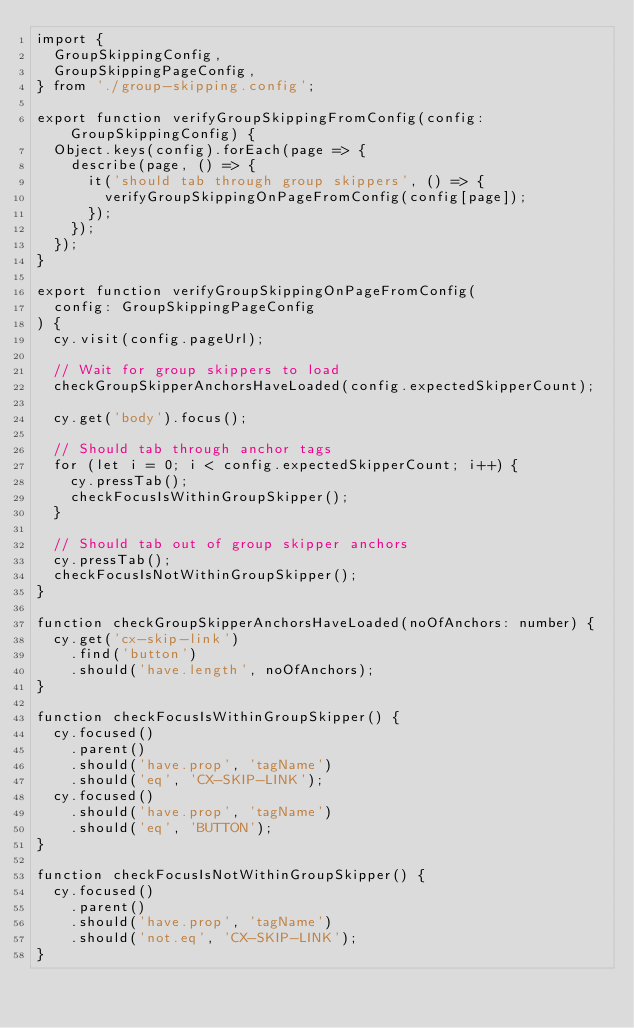<code> <loc_0><loc_0><loc_500><loc_500><_TypeScript_>import {
  GroupSkippingConfig,
  GroupSkippingPageConfig,
} from './group-skipping.config';

export function verifyGroupSkippingFromConfig(config: GroupSkippingConfig) {
  Object.keys(config).forEach(page => {
    describe(page, () => {
      it('should tab through group skippers', () => {
        verifyGroupSkippingOnPageFromConfig(config[page]);
      });
    });
  });
}

export function verifyGroupSkippingOnPageFromConfig(
  config: GroupSkippingPageConfig
) {
  cy.visit(config.pageUrl);

  // Wait for group skippers to load
  checkGroupSkipperAnchorsHaveLoaded(config.expectedSkipperCount);

  cy.get('body').focus();

  // Should tab through anchor tags
  for (let i = 0; i < config.expectedSkipperCount; i++) {
    cy.pressTab();
    checkFocusIsWithinGroupSkipper();
  }

  // Should tab out of group skipper anchors
  cy.pressTab();
  checkFocusIsNotWithinGroupSkipper();
}

function checkGroupSkipperAnchorsHaveLoaded(noOfAnchors: number) {
  cy.get('cx-skip-link')
    .find('button')
    .should('have.length', noOfAnchors);
}

function checkFocusIsWithinGroupSkipper() {
  cy.focused()
    .parent()
    .should('have.prop', 'tagName')
    .should('eq', 'CX-SKIP-LINK');
  cy.focused()
    .should('have.prop', 'tagName')
    .should('eq', 'BUTTON');
}

function checkFocusIsNotWithinGroupSkipper() {
  cy.focused()
    .parent()
    .should('have.prop', 'tagName')
    .should('not.eq', 'CX-SKIP-LINK');
}
</code> 